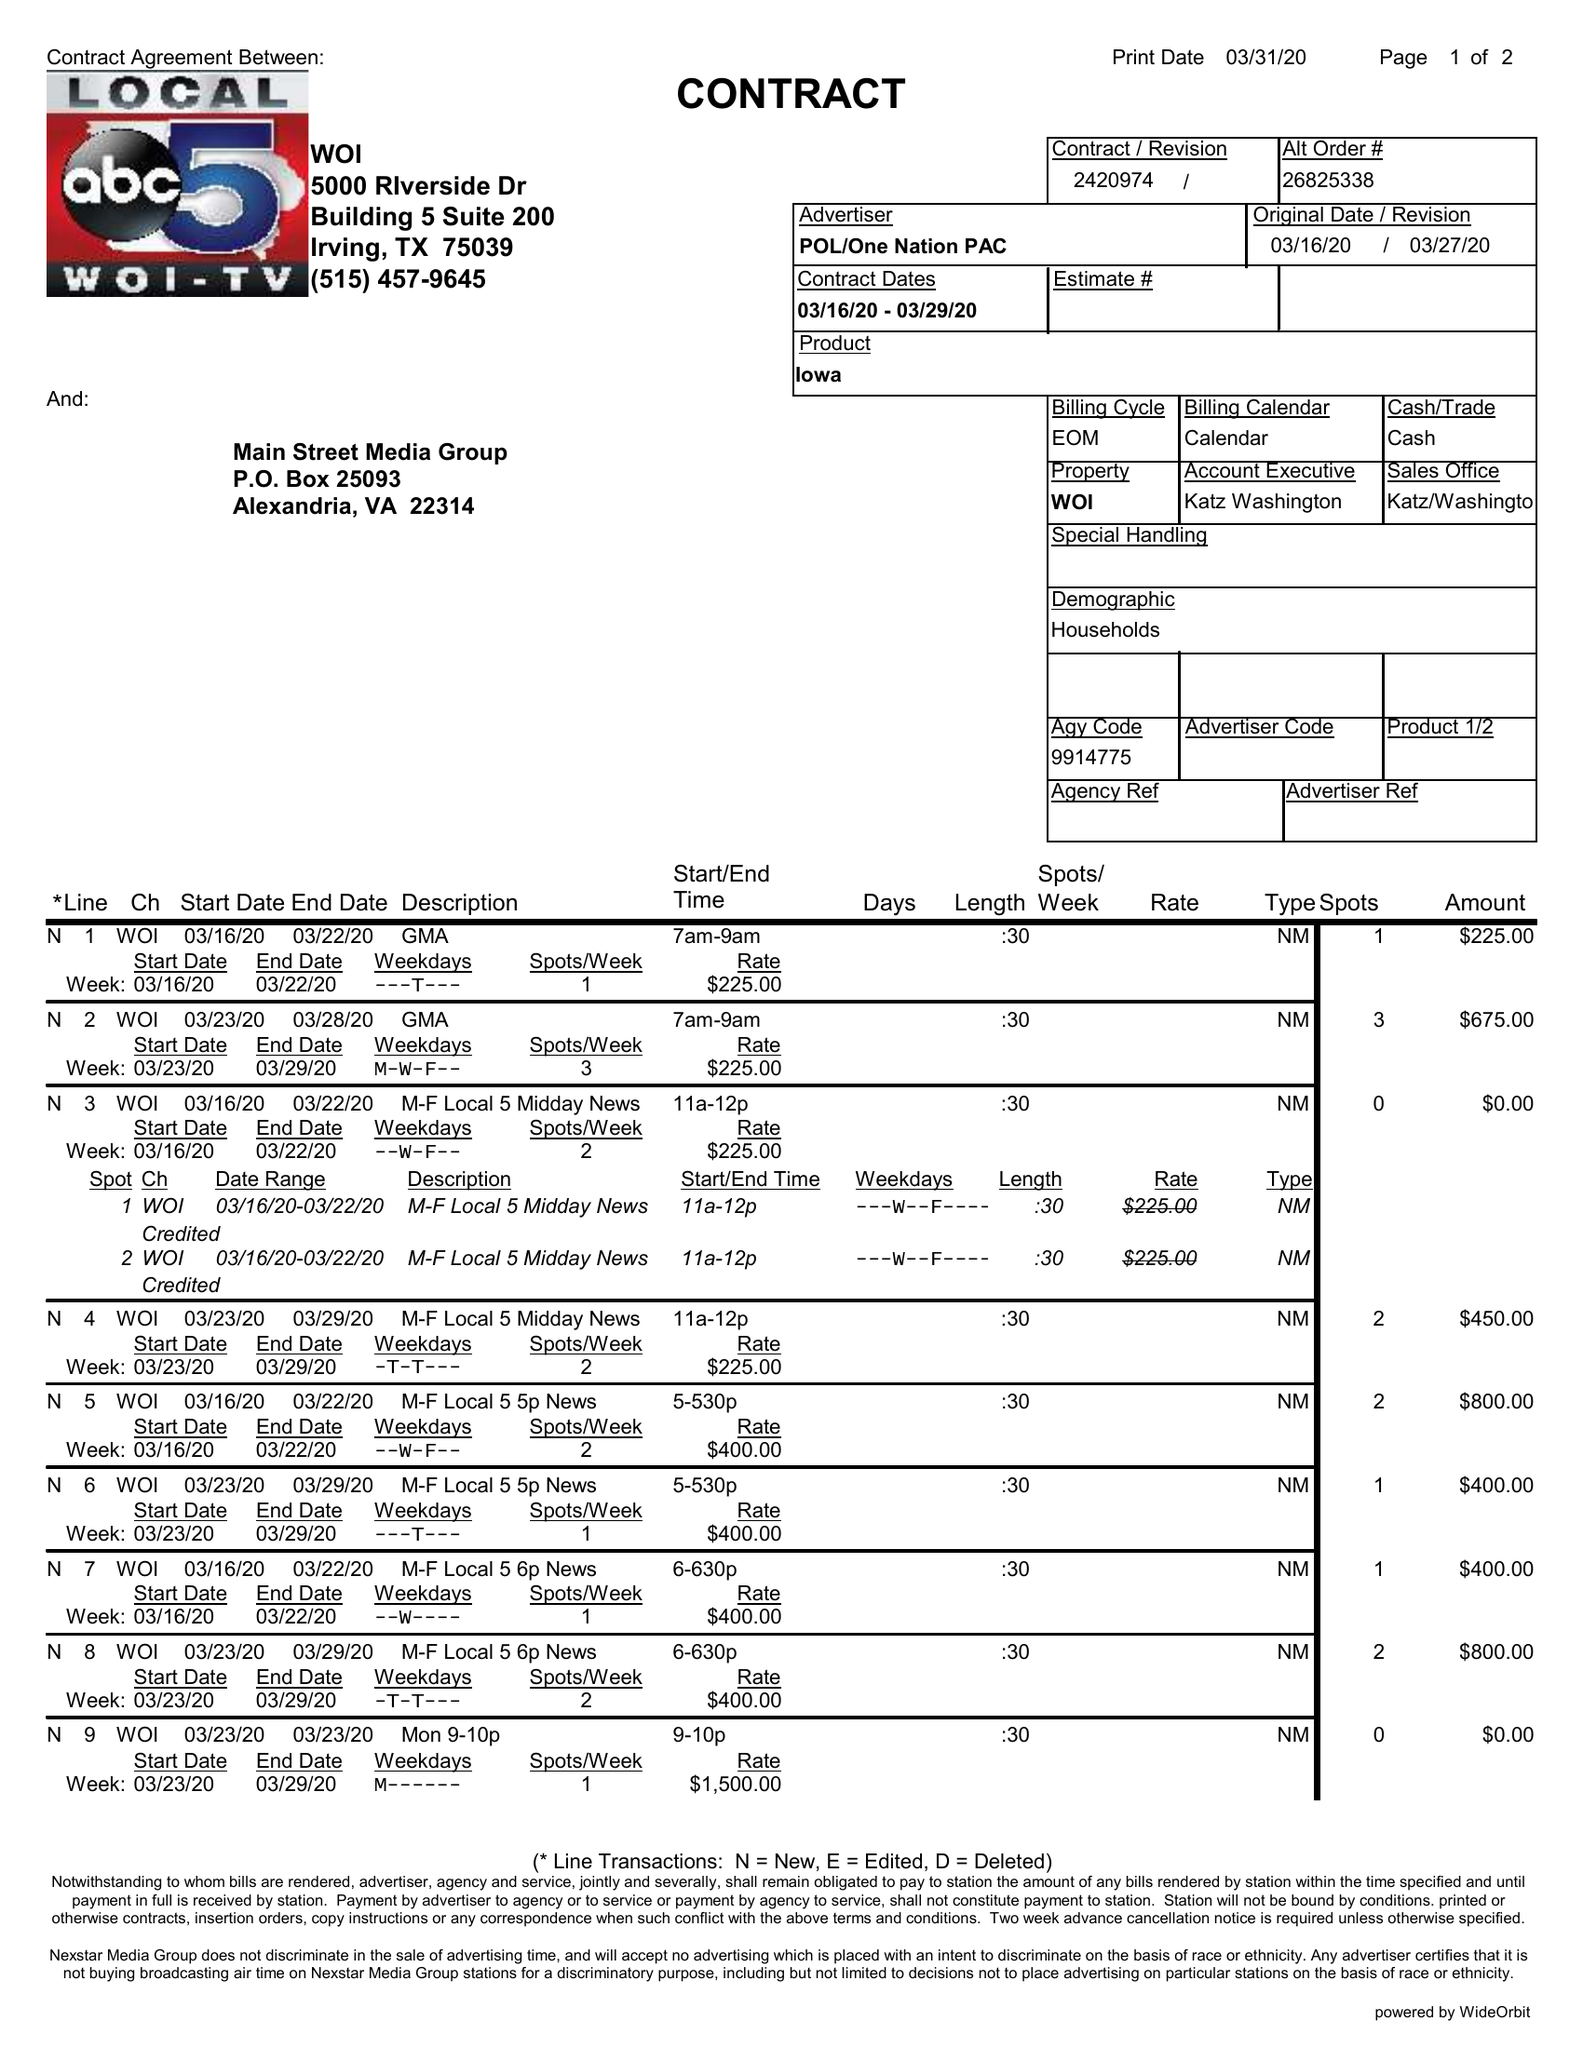What is the value for the flight_from?
Answer the question using a single word or phrase. 03/16/20 